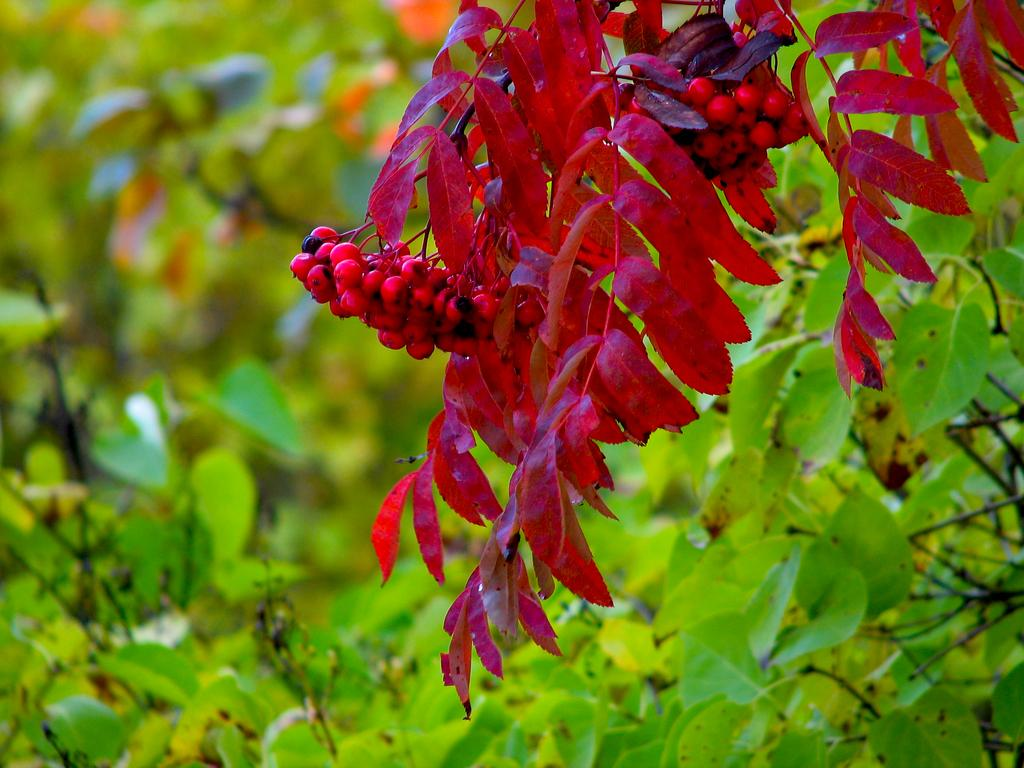What type of vegetation can be seen in the image? There are trees in the image. Can you describe the trees in the image? The provided facts do not give specific details about the trees, so we cannot describe them further. What might be the purpose of the trees in the image? The purpose of the trees in the image is not specified, but they could provide shade, serve as a habitat for wildlife, or be part of a landscape design. What type of veil can be seen covering the trees in the image? There is no veil present in the image; the trees are not covered. 